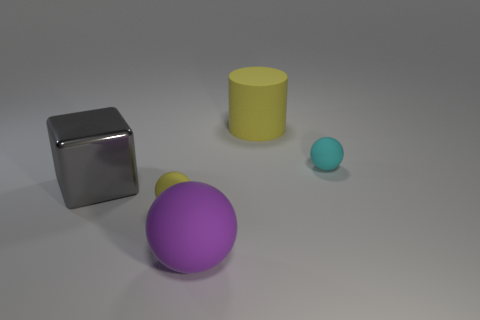Add 1 tiny yellow spheres. How many objects exist? 6 Subtract all tiny spheres. How many spheres are left? 1 Subtract 1 balls. How many balls are left? 2 Subtract all purple spheres. How many spheres are left? 2 Subtract all blocks. How many objects are left? 4 Add 5 tiny red cylinders. How many tiny red cylinders exist? 5 Subtract 0 blue cubes. How many objects are left? 5 Subtract all yellow cubes. Subtract all gray cylinders. How many cubes are left? 1 Subtract all big yellow rubber objects. Subtract all yellow rubber things. How many objects are left? 2 Add 1 tiny yellow matte balls. How many tiny yellow matte balls are left? 2 